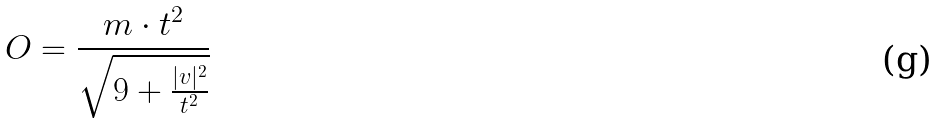<formula> <loc_0><loc_0><loc_500><loc_500>O = \frac { m \cdot t ^ { 2 } } { \sqrt { 9 + \frac { | v | ^ { 2 } } { t ^ { 2 } } } }</formula> 